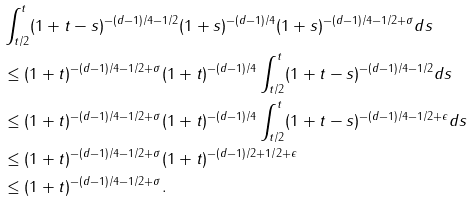Convert formula to latex. <formula><loc_0><loc_0><loc_500><loc_500>& \int _ { t / 2 } ^ { t } ( 1 + t - s ) ^ { - ( d - 1 ) / 4 - 1 / 2 } ( 1 + s ) ^ { - ( d - 1 ) / 4 } ( 1 + s ) ^ { - ( d - 1 ) / 4 - 1 / 2 + \sigma } d s \\ & \leq ( 1 + t ) ^ { - ( d - 1 ) / 4 - 1 / 2 + \sigma } ( 1 + t ) ^ { - ( d - 1 ) / 4 } \int _ { t / 2 } ^ { t } ( 1 + t - s ) ^ { - ( d - 1 ) / 4 - 1 / 2 } d s \\ & \leq ( 1 + t ) ^ { - ( d - 1 ) / 4 - 1 / 2 + \sigma } ( 1 + t ) ^ { - ( d - 1 ) / 4 } \int _ { t / 2 } ^ { t } ( 1 + t - s ) ^ { - ( d - 1 ) / 4 - 1 / 2 + \epsilon } d s \\ & \leq ( 1 + t ) ^ { - ( d - 1 ) / 4 - 1 / 2 + \sigma } ( 1 + t ) ^ { - ( d - 1 ) / 2 + 1 / 2 + \epsilon } \\ & \leq ( 1 + t ) ^ { - ( d - 1 ) / 4 - 1 / 2 + \sigma } .</formula> 